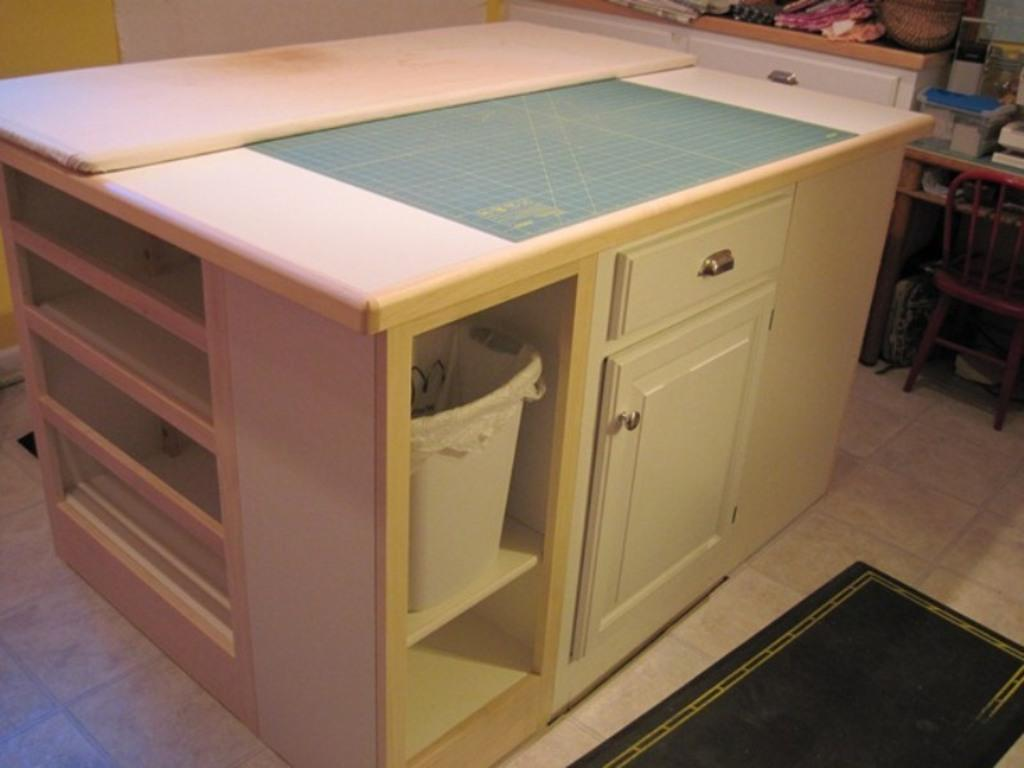What type of furniture is present in the image? There is a table and a chair in the image. What is located to the right of the table? There is a chair to the right of the table. What other object can be seen in the image? There is a dustbin in the image. What is on top of the table? There are objects on the table. Can you see any toads hopping on the table in the image? There are no toads present in the image. What type of trains can be seen passing by in the image? There are no trains visible in the image. 